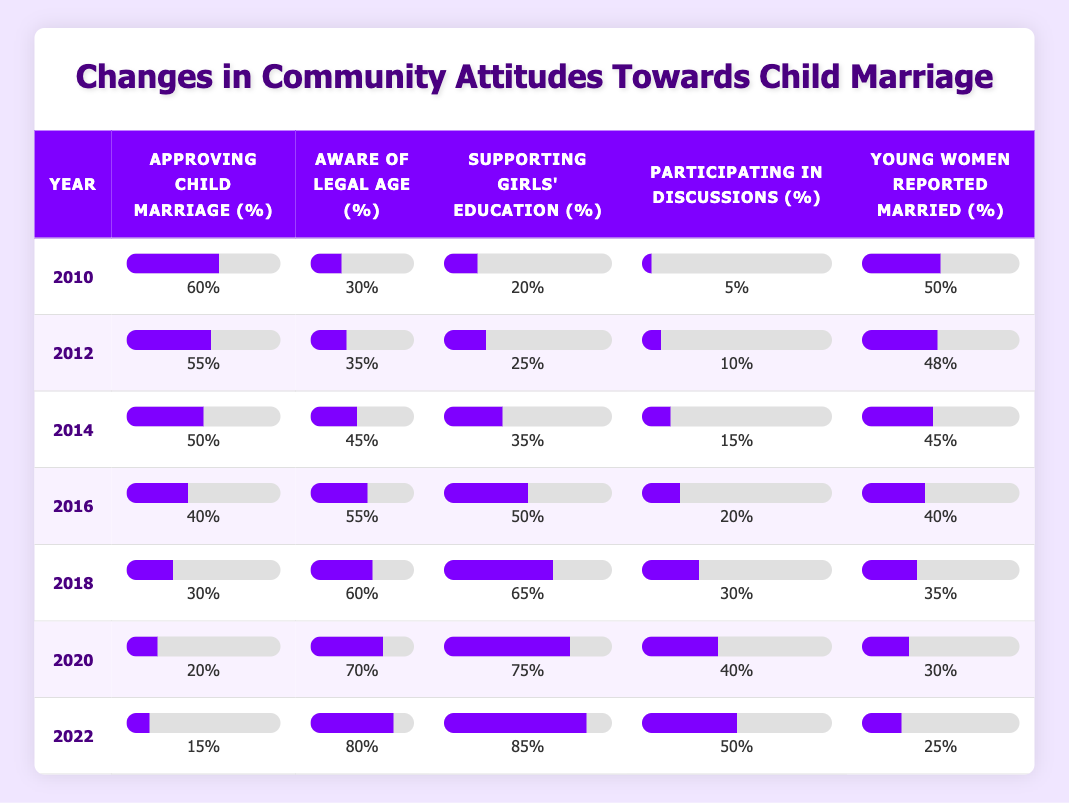What was the percentage of the community approving child marriage in 2010? In the row for the year 2010, the value in the column for "Approving Child Marriage (%)" is 60.
Answer: 60% What is the percentage of young women reported married in 2022? From the row for the year 2022, the percentage indicated under "Young Women Reported Married (%)" is 25.
Answer: 25% How many years had at least 50% of the community approving child marriage? By reviewing each row, the years 2010, 2012, and 2014 show percentages of approving child marriage at 60%, 55%, and 50% respectively. This totals 3 years.
Answer: 3 What is the trend in the percentage of community awareness of the legal age from 2010 to 2022? The percentages for "Aware of Legal Age (%)" from 2010 to 2022 are 30, 35, 45, 55, 60, 70, and 80 respectively. The trend shows a steady increase across all years.
Answer: Increase What was the average percentage of support for education for girls over the years? To find the average percentage of "Supporting Girls' Education (%)", we sum the values: (20 + 25 + 35 + 50 + 65 + 75 + 85) = 455. We then divide by the number of years (7): 455 / 7 = 65.
Answer: 65 Was the participation in community discussions higher in 2018 than in 2010? Looking at the rows for 2010 and 2018, the percentages for "Participating in Discussions (%)" are 5 and 30 respectively. Since 30 is greater than 5, the statement is true.
Answer: Yes Which year had the lowest percentage of young women reported married and what was it? The percentages for "Young Women Reported Married (%)" are 50, 48, 45, 40, 35, 30, and 25 for the years respectively. The lowest percentage is 25 in 2022.
Answer: 2022, 25 What is the percentage difference in support for girls' education between 2010 and 2020? From the respective years, the percentages are 20% in 2010 and 75% in 2020. The difference is calculated as 75 - 20 = 55.
Answer: 55 Did the community become more aware of the legal age from 2010 to 2022? Analyze the years: 30% in 2010 and 80% in 2022 indicates an increase, confirming that awareness improved over time.
Answer: Yes 